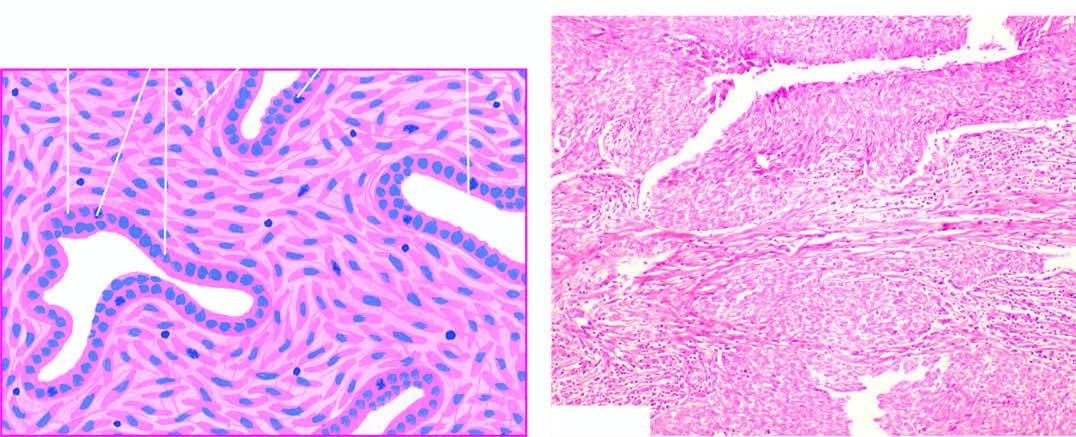what forming fibrosarcoma-like growth pattern?
Answer the question using a single word or phrase. Spindle cell areas 